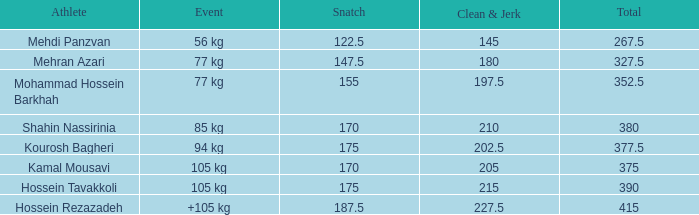How many instances involved an event of over 105 kg and a clean & jerk of less than 227.5? 0.0. 